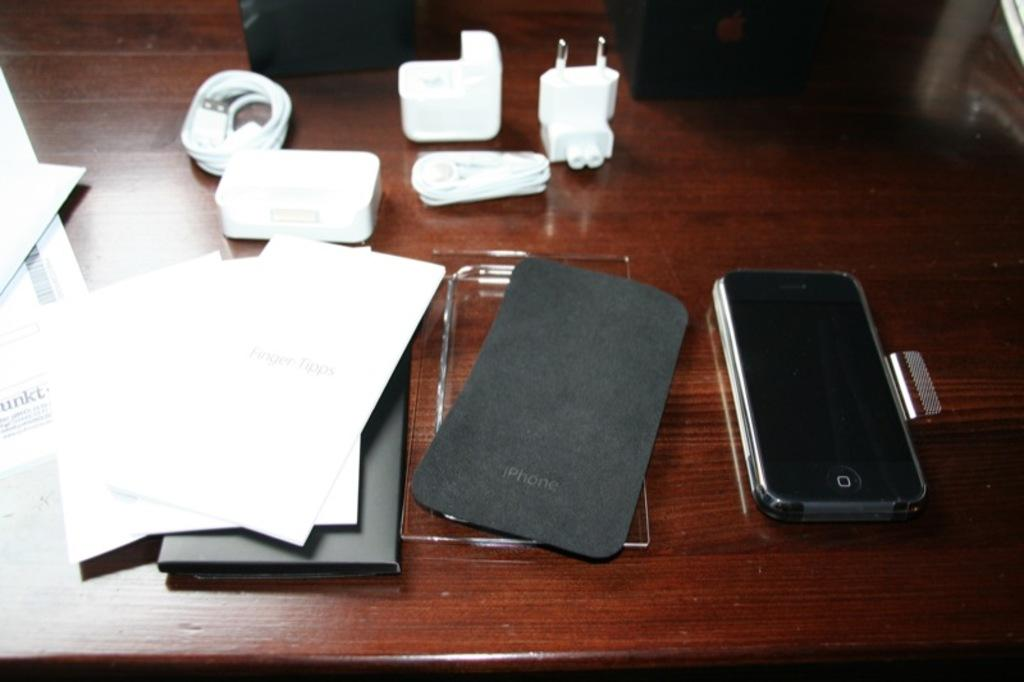<image>
Provide a brief description of the given image. a new iphone sitting next to a case that is labeled 'iphone' 